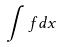<formula> <loc_0><loc_0><loc_500><loc_500>\int f d x</formula> 